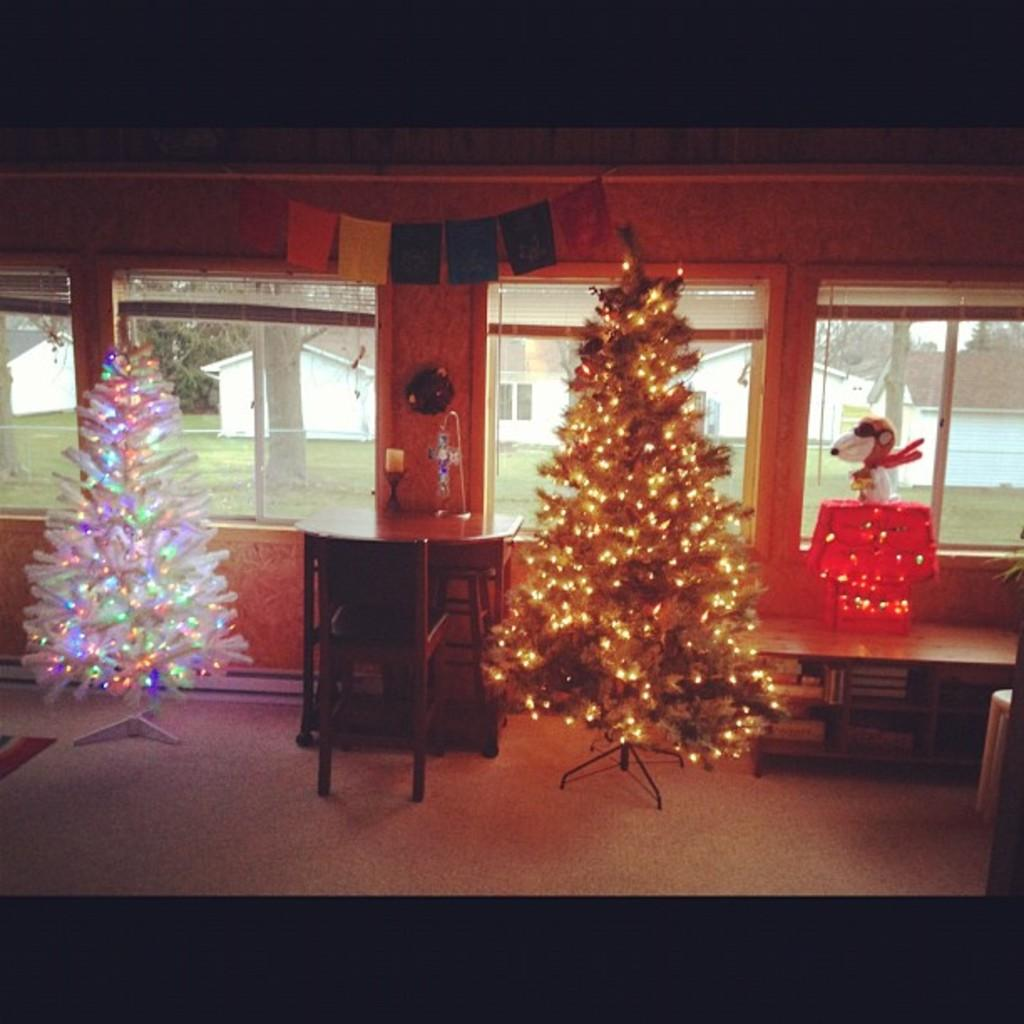What type of decorations are present in the image? There are Christmas trees in the image. What piece of furniture can be seen in the image? There is a table in the image. What type of seating is available in the image? There are chairs in the image. What type of flooring is visible in the image? There is a carpet in the image. What can be seen through the window in the background of the image? There is a glass window in the background of the image, and trees and houses can be seen through it. What type of riddle can be solved using the calculator in the image? There is no calculator present in the image, so no riddle can be solved using it. What type of hall is visible in the image? There is no hall visible in the image; the focus is on the Christmas trees, table, chairs, carpet, and the view through the window. 